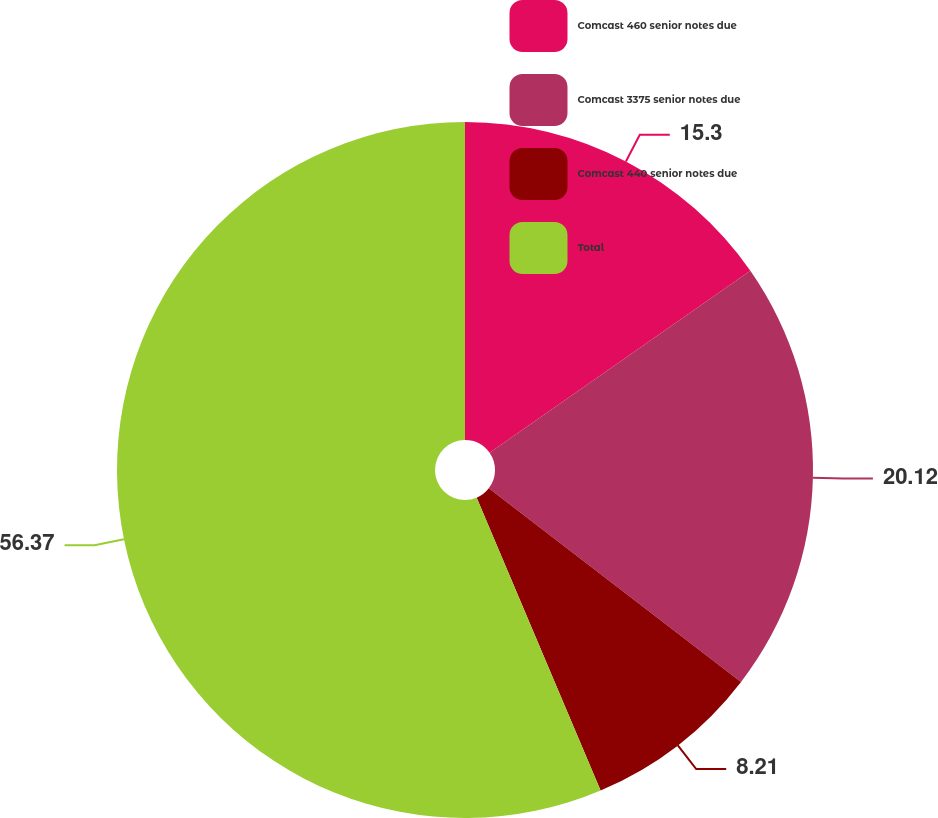Convert chart. <chart><loc_0><loc_0><loc_500><loc_500><pie_chart><fcel>Comcast 460 senior notes due<fcel>Comcast 3375 senior notes due<fcel>Comcast 440 senior notes due<fcel>Total<nl><fcel>15.3%<fcel>20.12%<fcel>8.21%<fcel>56.37%<nl></chart> 